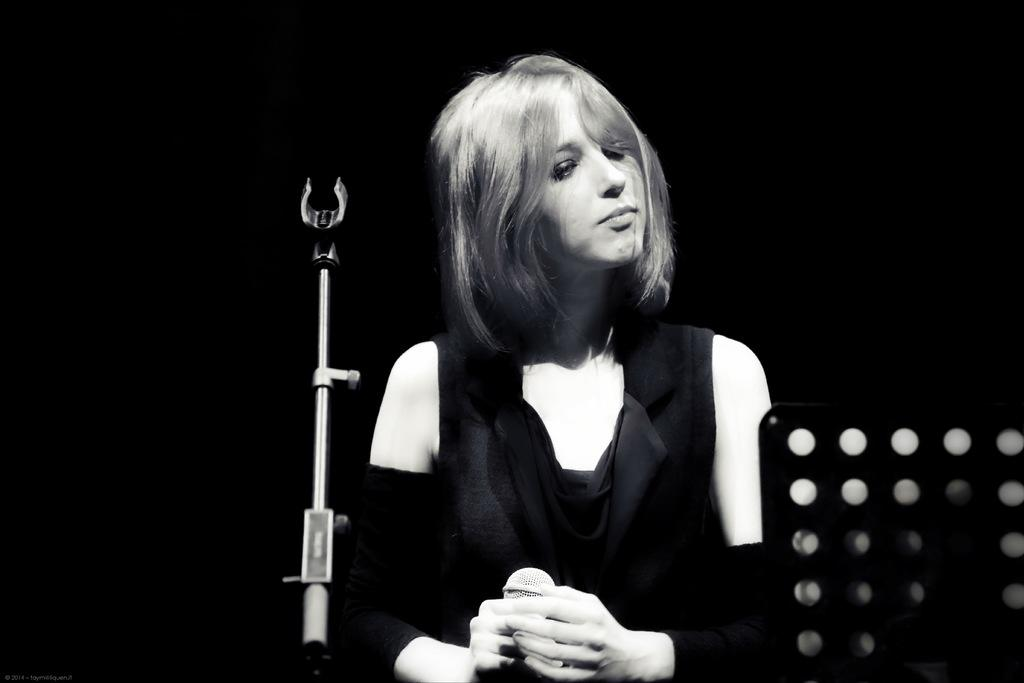What is the main subject of the image? The main subject of the image is a woman. Can you describe what the woman is wearing? The woman is wearing a black skirt. What object is in front of the woman? There is a microphone (mike) in front of the woman. What is the woman holding in the image? The woman is holding an object. What crime is the woman committing in the image? There is no indication of a crime being committed in the image. How many people are in jail can be seen in the image? There are no people in jail visible in the image. 